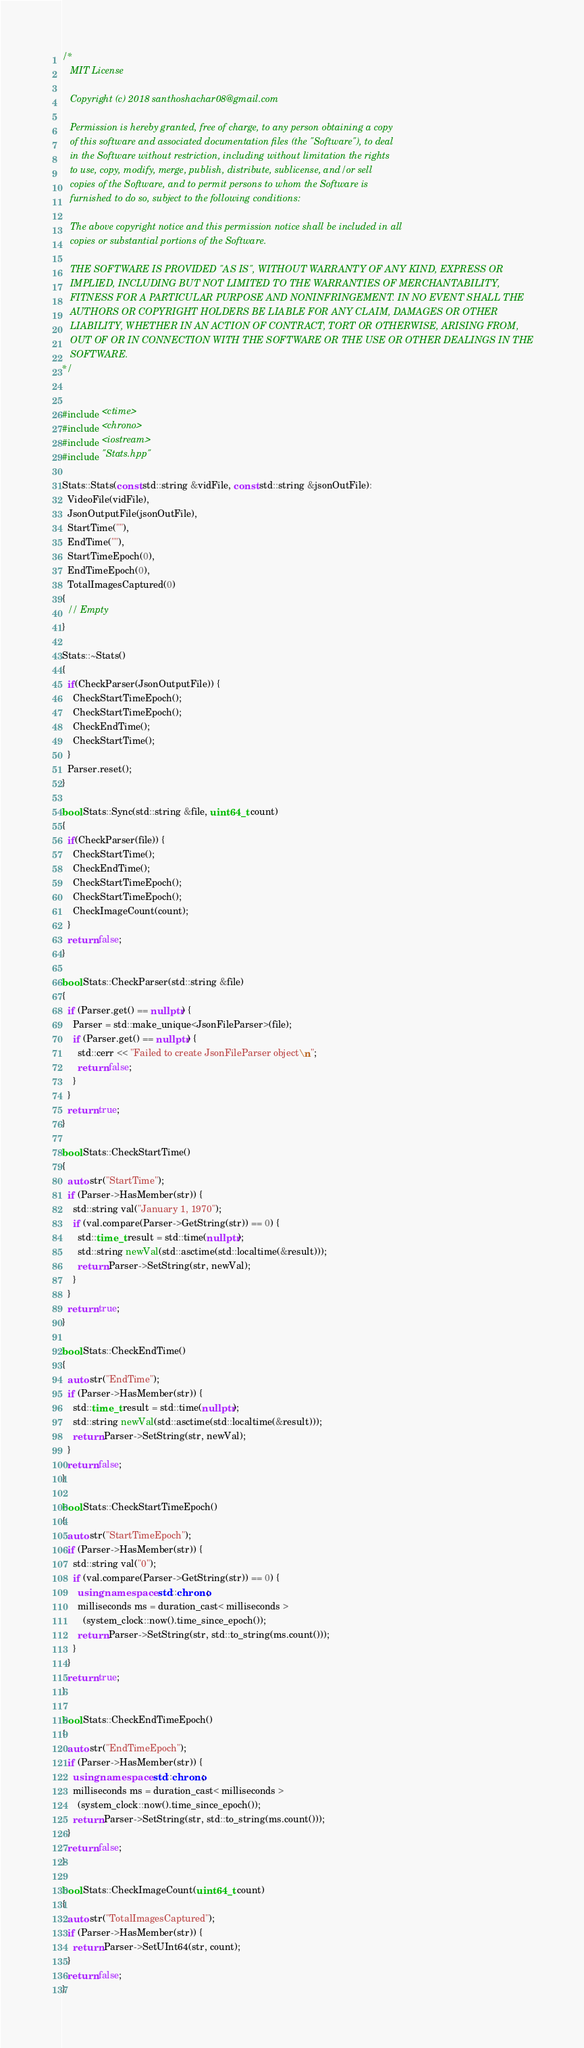<code> <loc_0><loc_0><loc_500><loc_500><_C++_>/*
   MIT License

   Copyright (c) 2018 santhoshachar08@gmail.com

   Permission is hereby granted, free of charge, to any person obtaining a copy
   of this software and associated documentation files (the "Software"), to deal
   in the Software without restriction, including without limitation the rights
   to use, copy, modify, merge, publish, distribute, sublicense, and/or sell
   copies of the Software, and to permit persons to whom the Software is
   furnished to do so, subject to the following conditions:

   The above copyright notice and this permission notice shall be included in all
   copies or substantial portions of the Software.

   THE SOFTWARE IS PROVIDED "AS IS", WITHOUT WARRANTY OF ANY KIND, EXPRESS OR
   IMPLIED, INCLUDING BUT NOT LIMITED TO THE WARRANTIES OF MERCHANTABILITY,
   FITNESS FOR A PARTICULAR PURPOSE AND NONINFRINGEMENT. IN NO EVENT SHALL THE
   AUTHORS OR COPYRIGHT HOLDERS BE LIABLE FOR ANY CLAIM, DAMAGES OR OTHER
   LIABILITY, WHETHER IN AN ACTION OF CONTRACT, TORT OR OTHERWISE, ARISING FROM,
   OUT OF OR IN CONNECTION WITH THE SOFTWARE OR THE USE OR OTHER DEALINGS IN THE
   SOFTWARE.
*/


#include <ctime>
#include <chrono>
#include <iostream>
#include "Stats.hpp"

Stats::Stats(const std::string &vidFile, const std::string &jsonOutFile):
  VideoFile(vidFile),
  JsonOutputFile(jsonOutFile),
  StartTime(""),
  EndTime(""),
  StartTimeEpoch(0),
  EndTimeEpoch(0),
  TotalImagesCaptured(0)
{
  // Empty
}

Stats::~Stats()
{
  if(CheckParser(JsonOutputFile)) {
    CheckStartTimeEpoch();
    CheckStartTimeEpoch();
    CheckEndTime();
    CheckStartTime();
  }
  Parser.reset();
}

bool Stats::Sync(std::string &file, uint64_t count)
{
  if(CheckParser(file)) {
    CheckStartTime();
    CheckEndTime();
    CheckStartTimeEpoch();
    CheckStartTimeEpoch();
    CheckImageCount(count);
  }
  return false;
}

bool Stats::CheckParser(std::string &file)
{
  if (Parser.get() == nullptr) {
    Parser = std::make_unique<JsonFileParser>(file);
    if (Parser.get() == nullptr) {
      std::cerr << "Failed to create JsonFileParser object\n";
      return false;
    }
  }
  return true;
}

bool Stats::CheckStartTime()
{
  auto str("StartTime");
  if (Parser->HasMember(str)) {
    std::string val("January 1, 1970");
    if (val.compare(Parser->GetString(str)) == 0) {
      std::time_t result = std::time(nullptr);
      std::string newVal(std::asctime(std::localtime(&result)));
      return Parser->SetString(str, newVal);
    }
  }
  return true;
}

bool Stats::CheckEndTime()
{
  auto str("EndTime");
  if (Parser->HasMember(str)) {
    std::time_t result = std::time(nullptr);
    std::string newVal(std::asctime(std::localtime(&result)));
    return Parser->SetString(str, newVal);
  }
  return false;
}

bool Stats::CheckStartTimeEpoch()
{
  auto str("StartTimeEpoch");
  if (Parser->HasMember(str)) {
    std::string val("0");
    if (val.compare(Parser->GetString(str)) == 0) {
      using namespace  std::chrono;
      milliseconds ms = duration_cast< milliseconds >
        (system_clock::now().time_since_epoch());
      return Parser->SetString(str, std::to_string(ms.count()));
    }
  }
  return true;
}

bool Stats::CheckEndTimeEpoch()
{
  auto str("EndTimeEpoch");
  if (Parser->HasMember(str)) {
    using namespace  std::chrono;
    milliseconds ms = duration_cast< milliseconds >
      (system_clock::now().time_since_epoch());
    return Parser->SetString(str, std::to_string(ms.count()));
  }
  return false;
}

bool Stats::CheckImageCount(uint64_t count)
{
  auto str("TotalImagesCaptured");
  if (Parser->HasMember(str)) {
    return Parser->SetUInt64(str, count);
  }
  return false;
}
</code> 